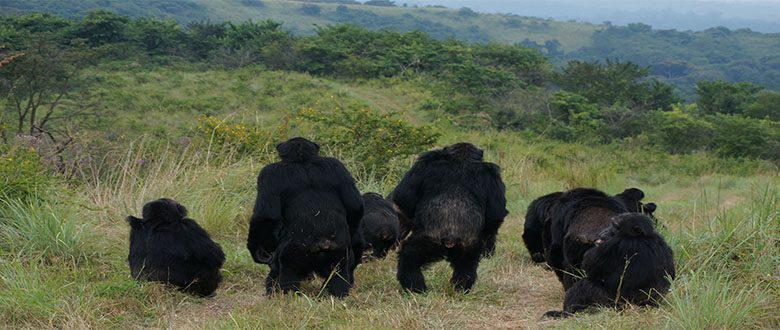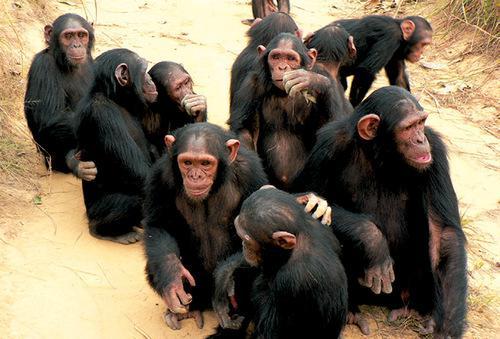The first image is the image on the left, the second image is the image on the right. Evaluate the accuracy of this statement regarding the images: "A baby ape is touching an adult ape's hand". Is it true? Answer yes or no. No. The first image is the image on the left, the second image is the image on the right. Assess this claim about the two images: "An image features one trio of interacting chimps facing forward.". Correct or not? Answer yes or no. No. 